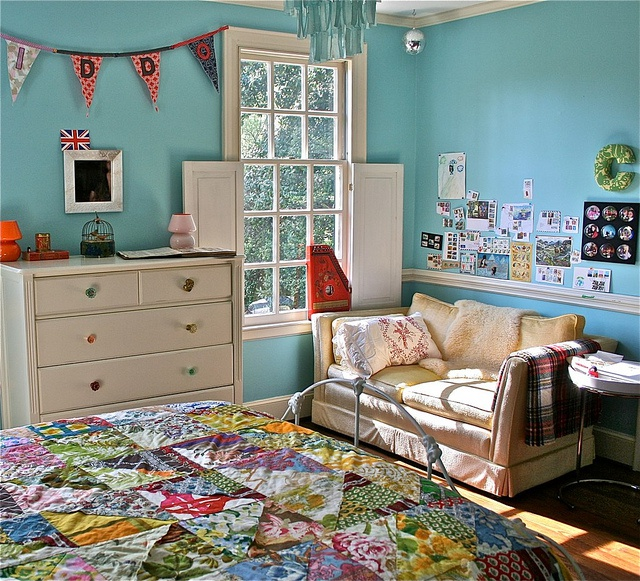Describe the objects in this image and their specific colors. I can see bed in lightblue, darkgray, gray, olive, and lightgray tones and couch in lightblue, white, tan, black, and gray tones in this image. 